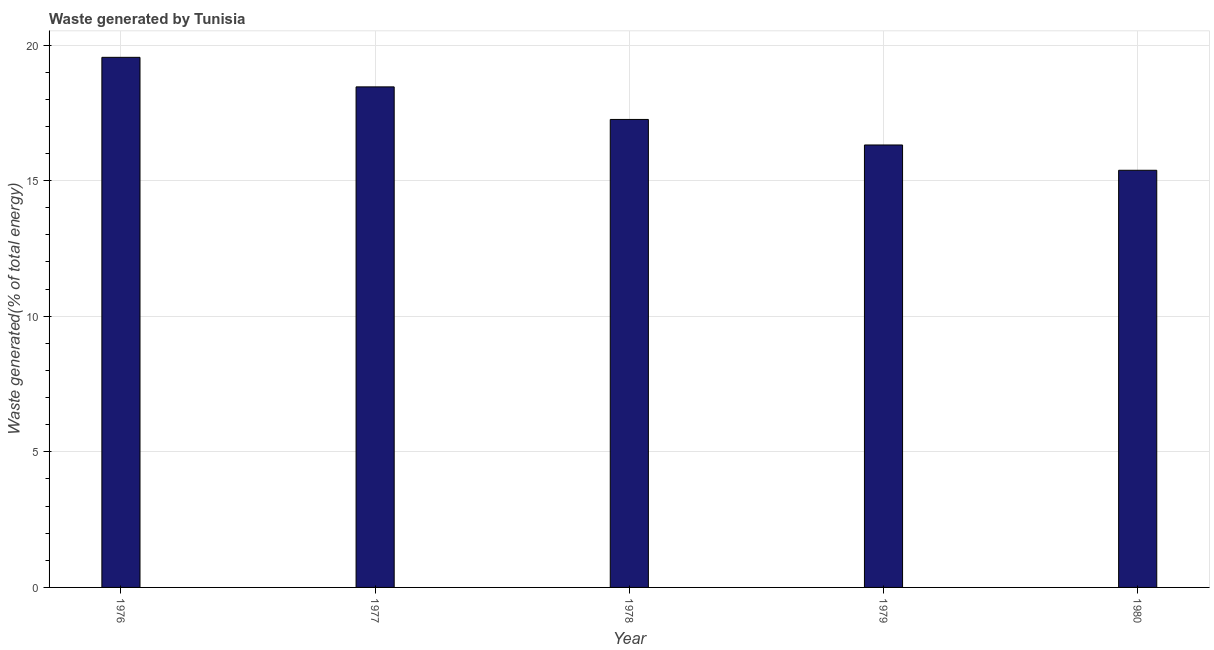What is the title of the graph?
Offer a terse response. Waste generated by Tunisia. What is the label or title of the X-axis?
Your answer should be very brief. Year. What is the label or title of the Y-axis?
Give a very brief answer. Waste generated(% of total energy). What is the amount of waste generated in 1978?
Offer a very short reply. 17.26. Across all years, what is the maximum amount of waste generated?
Provide a short and direct response. 19.55. Across all years, what is the minimum amount of waste generated?
Give a very brief answer. 15.38. In which year was the amount of waste generated maximum?
Your answer should be very brief. 1976. In which year was the amount of waste generated minimum?
Your answer should be very brief. 1980. What is the sum of the amount of waste generated?
Provide a succinct answer. 86.95. What is the difference between the amount of waste generated in 1977 and 1978?
Give a very brief answer. 1.2. What is the average amount of waste generated per year?
Your answer should be compact. 17.39. What is the median amount of waste generated?
Make the answer very short. 17.26. What is the ratio of the amount of waste generated in 1976 to that in 1979?
Your answer should be very brief. 1.2. Is the amount of waste generated in 1977 less than that in 1979?
Ensure brevity in your answer.  No. What is the difference between the highest and the second highest amount of waste generated?
Provide a short and direct response. 1.09. What is the difference between the highest and the lowest amount of waste generated?
Give a very brief answer. 4.16. Are all the bars in the graph horizontal?
Ensure brevity in your answer.  No. How many years are there in the graph?
Provide a succinct answer. 5. What is the Waste generated(% of total energy) of 1976?
Your response must be concise. 19.55. What is the Waste generated(% of total energy) in 1977?
Keep it short and to the point. 18.46. What is the Waste generated(% of total energy) of 1978?
Offer a very short reply. 17.26. What is the Waste generated(% of total energy) of 1979?
Your answer should be very brief. 16.31. What is the Waste generated(% of total energy) in 1980?
Ensure brevity in your answer.  15.38. What is the difference between the Waste generated(% of total energy) in 1976 and 1977?
Ensure brevity in your answer.  1.09. What is the difference between the Waste generated(% of total energy) in 1976 and 1978?
Your answer should be very brief. 2.29. What is the difference between the Waste generated(% of total energy) in 1976 and 1979?
Your answer should be very brief. 3.23. What is the difference between the Waste generated(% of total energy) in 1976 and 1980?
Make the answer very short. 4.16. What is the difference between the Waste generated(% of total energy) in 1977 and 1978?
Make the answer very short. 1.2. What is the difference between the Waste generated(% of total energy) in 1977 and 1979?
Offer a very short reply. 2.14. What is the difference between the Waste generated(% of total energy) in 1977 and 1980?
Ensure brevity in your answer.  3.08. What is the difference between the Waste generated(% of total energy) in 1978 and 1979?
Offer a terse response. 0.94. What is the difference between the Waste generated(% of total energy) in 1978 and 1980?
Give a very brief answer. 1.87. What is the difference between the Waste generated(% of total energy) in 1979 and 1980?
Give a very brief answer. 0.93. What is the ratio of the Waste generated(% of total energy) in 1976 to that in 1977?
Provide a succinct answer. 1.06. What is the ratio of the Waste generated(% of total energy) in 1976 to that in 1978?
Ensure brevity in your answer.  1.13. What is the ratio of the Waste generated(% of total energy) in 1976 to that in 1979?
Your answer should be compact. 1.2. What is the ratio of the Waste generated(% of total energy) in 1976 to that in 1980?
Offer a very short reply. 1.27. What is the ratio of the Waste generated(% of total energy) in 1977 to that in 1978?
Provide a succinct answer. 1.07. What is the ratio of the Waste generated(% of total energy) in 1977 to that in 1979?
Your answer should be compact. 1.13. What is the ratio of the Waste generated(% of total energy) in 1978 to that in 1979?
Your response must be concise. 1.06. What is the ratio of the Waste generated(% of total energy) in 1978 to that in 1980?
Provide a short and direct response. 1.12. What is the ratio of the Waste generated(% of total energy) in 1979 to that in 1980?
Your answer should be compact. 1.06. 